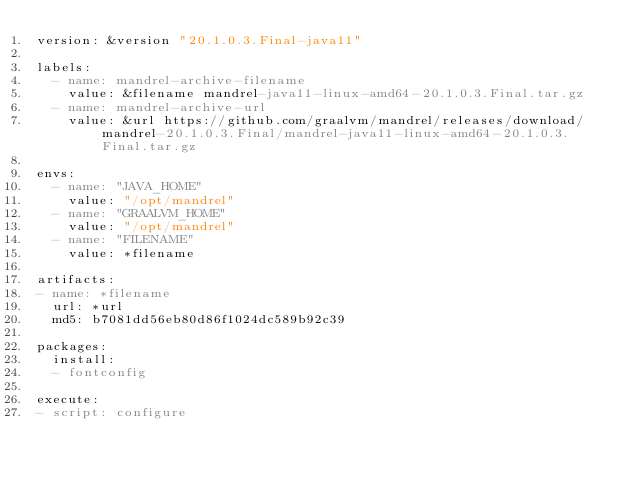Convert code to text. <code><loc_0><loc_0><loc_500><loc_500><_YAML_>version: &version "20.1.0.3.Final-java11"

labels:
  - name: mandrel-archive-filename
    value: &filename mandrel-java11-linux-amd64-20.1.0.3.Final.tar.gz
  - name: mandrel-archive-url
    value: &url https://github.com/graalvm/mandrel/releases/download/mandrel-20.1.0.3.Final/mandrel-java11-linux-amd64-20.1.0.3.Final.tar.gz

envs:
  - name: "JAVA_HOME"
    value: "/opt/mandrel"
  - name: "GRAALVM_HOME"
    value: "/opt/mandrel"
  - name: "FILENAME"
    value: *filename

artifacts:
- name: *filename
  url: *url
  md5: b7081dd56eb80d86f1024dc589b92c39

packages:
  install:
  - fontconfig

execute:
- script: configure
</code> 